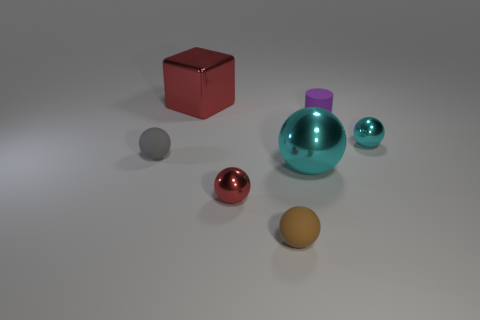What number of gray matte balls are to the right of the brown thing?
Your answer should be compact. 0. Are there fewer purple objects on the left side of the large cyan sphere than gray spheres?
Give a very brief answer. Yes. The small cylinder has what color?
Make the answer very short. Purple. Does the sphere that is left of the large red cube have the same color as the big metal block?
Keep it short and to the point. No. There is another small rubber object that is the same shape as the small brown thing; what color is it?
Ensure brevity in your answer.  Gray. How many large things are either metal cubes or cyan metallic spheres?
Your response must be concise. 2. How big is the red metal object left of the red shiny ball?
Provide a succinct answer. Large. Are there any other small matte cylinders of the same color as the cylinder?
Your answer should be compact. No. Is the color of the big shiny cube the same as the tiny rubber cylinder?
Your answer should be very brief. No. There is a thing that is the same color as the big ball; what is its shape?
Offer a terse response. Sphere. 